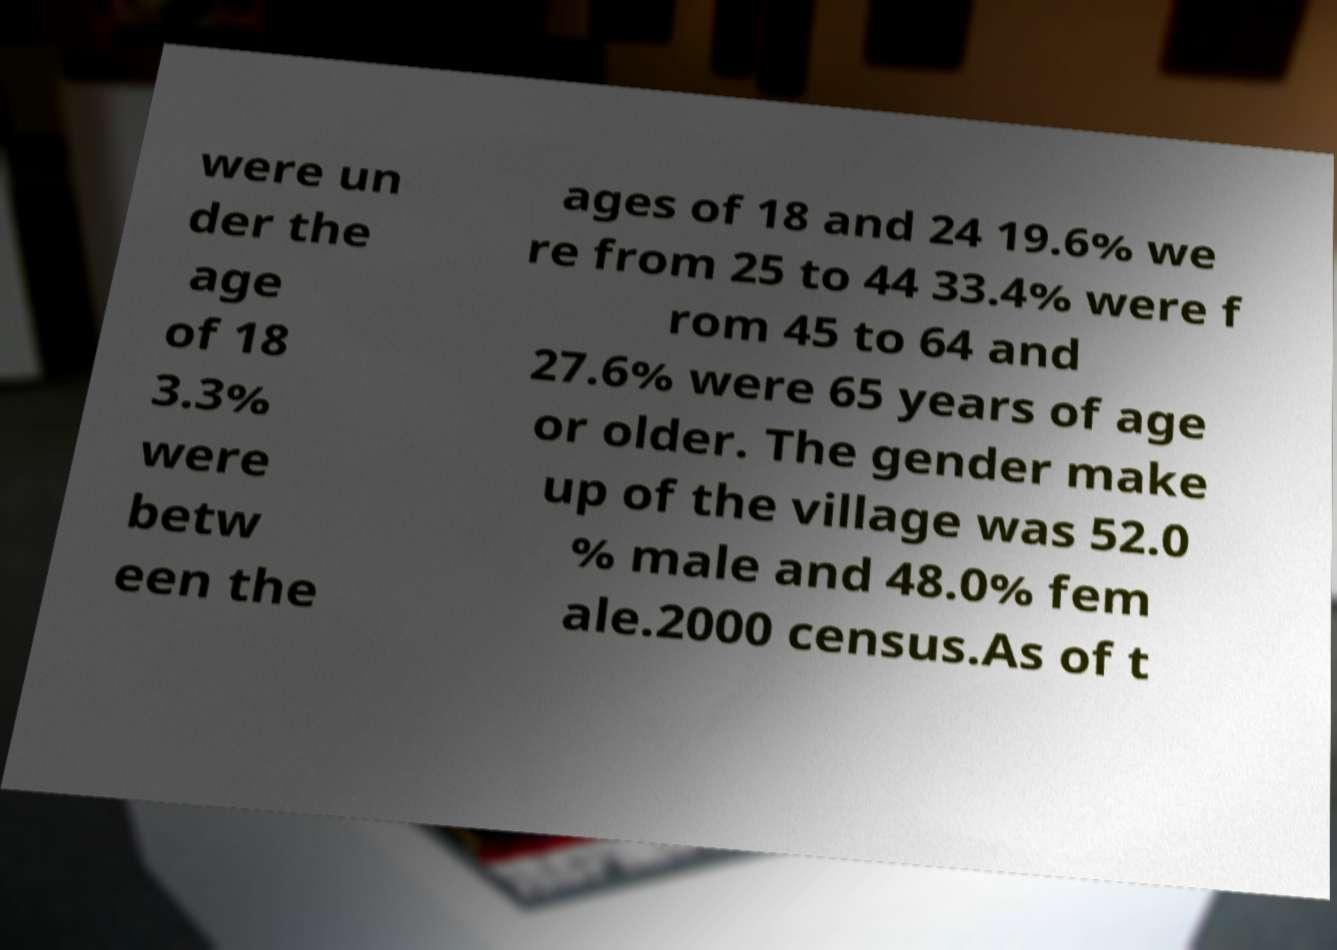For documentation purposes, I need the text within this image transcribed. Could you provide that? were un der the age of 18 3.3% were betw een the ages of 18 and 24 19.6% we re from 25 to 44 33.4% were f rom 45 to 64 and 27.6% were 65 years of age or older. The gender make up of the village was 52.0 % male and 48.0% fem ale.2000 census.As of t 